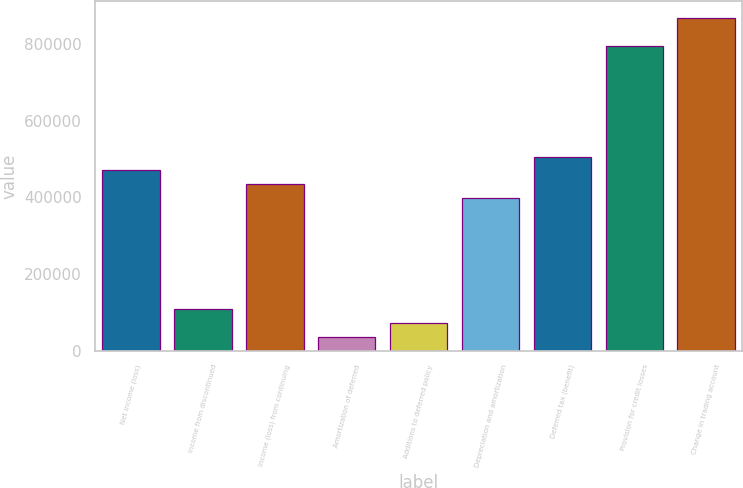Convert chart to OTSL. <chart><loc_0><loc_0><loc_500><loc_500><bar_chart><fcel>Net income (loss)<fcel>Income from discontinued<fcel>Income (loss) from continuing<fcel>Amortization of deferred<fcel>Additions to deferred policy<fcel>Depreciation and amortization<fcel>Deferred tax (benefit)<fcel>Provision for credit losses<fcel>Change in trading account<nl><fcel>470482<fcel>108655<fcel>434299<fcel>36289.7<fcel>72472.4<fcel>398117<fcel>506665<fcel>796126<fcel>868492<nl></chart> 